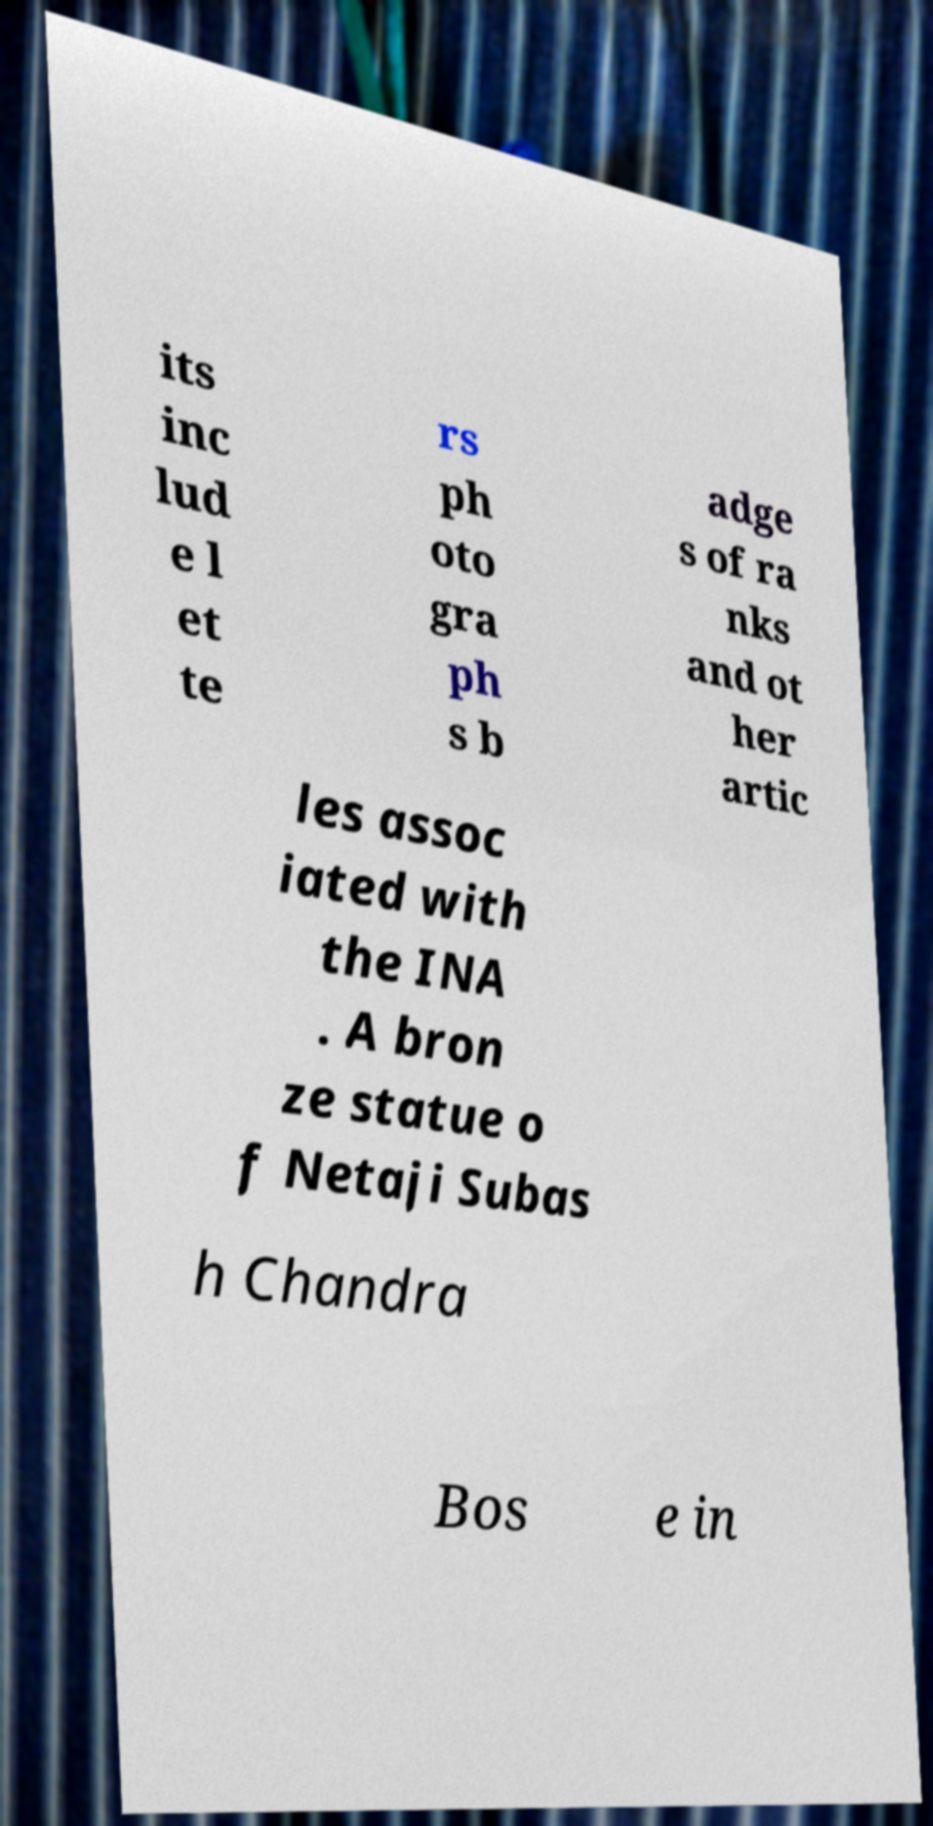Please read and relay the text visible in this image. What does it say? its inc lud e l et te rs ph oto gra ph s b adge s of ra nks and ot her artic les assoc iated with the INA . A bron ze statue o f Netaji Subas h Chandra Bos e in 